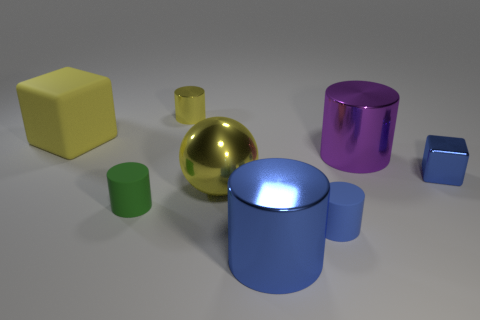Subtract all yellow cylinders. How many cylinders are left? 4 Subtract all small blue rubber cylinders. How many cylinders are left? 4 Subtract all green cylinders. Subtract all brown blocks. How many cylinders are left? 4 Add 2 yellow things. How many objects exist? 10 Subtract all balls. How many objects are left? 7 Subtract 0 red balls. How many objects are left? 8 Subtract all large yellow cubes. Subtract all tiny blue shiny objects. How many objects are left? 6 Add 6 blue shiny objects. How many blue shiny objects are left? 8 Add 3 large blue blocks. How many large blue blocks exist? 3 